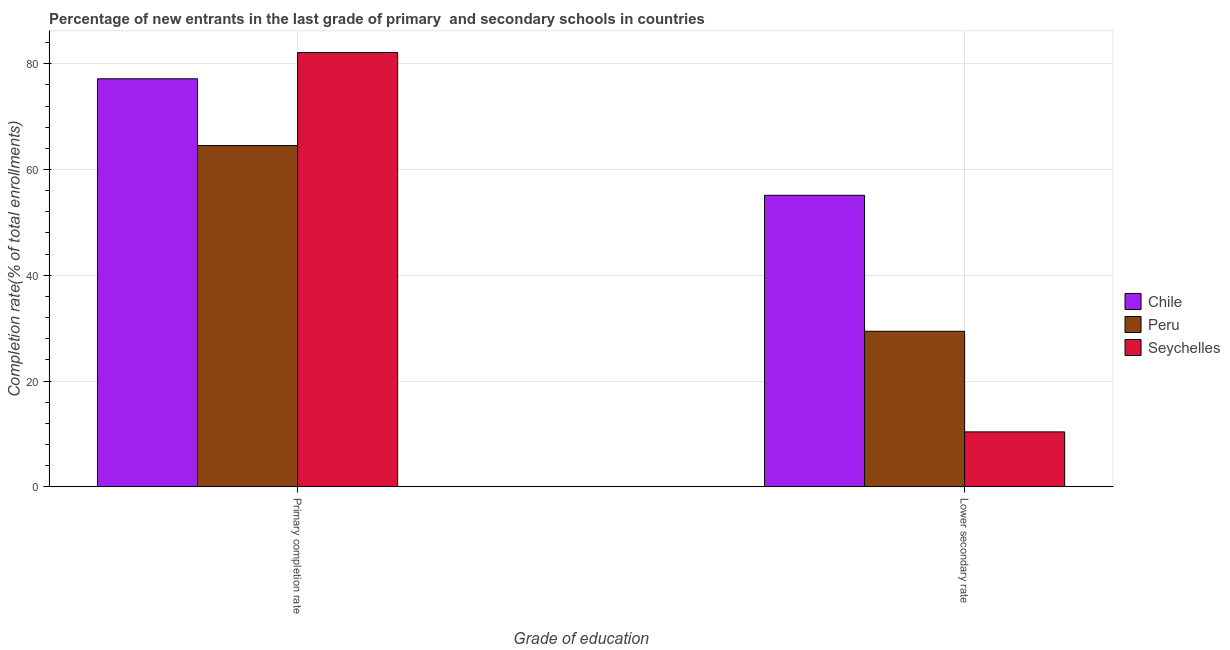How many different coloured bars are there?
Your answer should be very brief. 3. How many bars are there on the 1st tick from the left?
Make the answer very short. 3. What is the label of the 2nd group of bars from the left?
Your response must be concise. Lower secondary rate. What is the completion rate in secondary schools in Chile?
Provide a short and direct response. 55.13. Across all countries, what is the maximum completion rate in primary schools?
Offer a very short reply. 82.14. Across all countries, what is the minimum completion rate in primary schools?
Make the answer very short. 64.54. In which country was the completion rate in primary schools maximum?
Provide a short and direct response. Seychelles. In which country was the completion rate in secondary schools minimum?
Your answer should be very brief. Seychelles. What is the total completion rate in secondary schools in the graph?
Provide a succinct answer. 94.91. What is the difference between the completion rate in secondary schools in Seychelles and that in Peru?
Your response must be concise. -19.03. What is the difference between the completion rate in primary schools in Chile and the completion rate in secondary schools in Seychelles?
Your answer should be very brief. 66.8. What is the average completion rate in primary schools per country?
Your response must be concise. 74.61. What is the difference between the completion rate in primary schools and completion rate in secondary schools in Peru?
Provide a succinct answer. 35.13. In how many countries, is the completion rate in primary schools greater than 68 %?
Offer a very short reply. 2. What is the ratio of the completion rate in secondary schools in Chile to that in Seychelles?
Your response must be concise. 5.31. Is the completion rate in primary schools in Chile less than that in Seychelles?
Ensure brevity in your answer.  Yes. How many countries are there in the graph?
Offer a terse response. 3. What is the difference between two consecutive major ticks on the Y-axis?
Your answer should be very brief. 20. Where does the legend appear in the graph?
Keep it short and to the point. Center right. How many legend labels are there?
Give a very brief answer. 3. What is the title of the graph?
Offer a very short reply. Percentage of new entrants in the last grade of primary  and secondary schools in countries. What is the label or title of the X-axis?
Give a very brief answer. Grade of education. What is the label or title of the Y-axis?
Your answer should be compact. Completion rate(% of total enrollments). What is the Completion rate(% of total enrollments) of Chile in Primary completion rate?
Provide a short and direct response. 77.17. What is the Completion rate(% of total enrollments) of Peru in Primary completion rate?
Your response must be concise. 64.54. What is the Completion rate(% of total enrollments) in Seychelles in Primary completion rate?
Provide a short and direct response. 82.14. What is the Completion rate(% of total enrollments) in Chile in Lower secondary rate?
Keep it short and to the point. 55.13. What is the Completion rate(% of total enrollments) in Peru in Lower secondary rate?
Provide a short and direct response. 29.41. What is the Completion rate(% of total enrollments) of Seychelles in Lower secondary rate?
Your answer should be compact. 10.37. Across all Grade of education, what is the maximum Completion rate(% of total enrollments) of Chile?
Provide a succinct answer. 77.17. Across all Grade of education, what is the maximum Completion rate(% of total enrollments) in Peru?
Ensure brevity in your answer.  64.54. Across all Grade of education, what is the maximum Completion rate(% of total enrollments) in Seychelles?
Provide a short and direct response. 82.14. Across all Grade of education, what is the minimum Completion rate(% of total enrollments) of Chile?
Your response must be concise. 55.13. Across all Grade of education, what is the minimum Completion rate(% of total enrollments) of Peru?
Your answer should be compact. 29.41. Across all Grade of education, what is the minimum Completion rate(% of total enrollments) in Seychelles?
Make the answer very short. 10.37. What is the total Completion rate(% of total enrollments) in Chile in the graph?
Ensure brevity in your answer.  132.3. What is the total Completion rate(% of total enrollments) in Peru in the graph?
Give a very brief answer. 93.94. What is the total Completion rate(% of total enrollments) of Seychelles in the graph?
Your answer should be compact. 92.51. What is the difference between the Completion rate(% of total enrollments) in Chile in Primary completion rate and that in Lower secondary rate?
Your response must be concise. 22.04. What is the difference between the Completion rate(% of total enrollments) of Peru in Primary completion rate and that in Lower secondary rate?
Ensure brevity in your answer.  35.13. What is the difference between the Completion rate(% of total enrollments) in Seychelles in Primary completion rate and that in Lower secondary rate?
Give a very brief answer. 71.76. What is the difference between the Completion rate(% of total enrollments) in Chile in Primary completion rate and the Completion rate(% of total enrollments) in Peru in Lower secondary rate?
Ensure brevity in your answer.  47.76. What is the difference between the Completion rate(% of total enrollments) in Chile in Primary completion rate and the Completion rate(% of total enrollments) in Seychelles in Lower secondary rate?
Your answer should be compact. 66.8. What is the difference between the Completion rate(% of total enrollments) of Peru in Primary completion rate and the Completion rate(% of total enrollments) of Seychelles in Lower secondary rate?
Give a very brief answer. 54.16. What is the average Completion rate(% of total enrollments) of Chile per Grade of education?
Your response must be concise. 66.15. What is the average Completion rate(% of total enrollments) in Peru per Grade of education?
Your answer should be compact. 46.97. What is the average Completion rate(% of total enrollments) of Seychelles per Grade of education?
Keep it short and to the point. 46.26. What is the difference between the Completion rate(% of total enrollments) of Chile and Completion rate(% of total enrollments) of Peru in Primary completion rate?
Your response must be concise. 12.63. What is the difference between the Completion rate(% of total enrollments) in Chile and Completion rate(% of total enrollments) in Seychelles in Primary completion rate?
Offer a very short reply. -4.97. What is the difference between the Completion rate(% of total enrollments) in Peru and Completion rate(% of total enrollments) in Seychelles in Primary completion rate?
Ensure brevity in your answer.  -17.6. What is the difference between the Completion rate(% of total enrollments) of Chile and Completion rate(% of total enrollments) of Peru in Lower secondary rate?
Your response must be concise. 25.72. What is the difference between the Completion rate(% of total enrollments) of Chile and Completion rate(% of total enrollments) of Seychelles in Lower secondary rate?
Provide a succinct answer. 44.76. What is the difference between the Completion rate(% of total enrollments) in Peru and Completion rate(% of total enrollments) in Seychelles in Lower secondary rate?
Give a very brief answer. 19.03. What is the ratio of the Completion rate(% of total enrollments) of Chile in Primary completion rate to that in Lower secondary rate?
Provide a succinct answer. 1.4. What is the ratio of the Completion rate(% of total enrollments) in Peru in Primary completion rate to that in Lower secondary rate?
Your response must be concise. 2.19. What is the ratio of the Completion rate(% of total enrollments) in Seychelles in Primary completion rate to that in Lower secondary rate?
Make the answer very short. 7.92. What is the difference between the highest and the second highest Completion rate(% of total enrollments) of Chile?
Provide a succinct answer. 22.04. What is the difference between the highest and the second highest Completion rate(% of total enrollments) of Peru?
Your answer should be compact. 35.13. What is the difference between the highest and the second highest Completion rate(% of total enrollments) of Seychelles?
Offer a terse response. 71.76. What is the difference between the highest and the lowest Completion rate(% of total enrollments) in Chile?
Give a very brief answer. 22.04. What is the difference between the highest and the lowest Completion rate(% of total enrollments) in Peru?
Your answer should be very brief. 35.13. What is the difference between the highest and the lowest Completion rate(% of total enrollments) in Seychelles?
Your response must be concise. 71.76. 